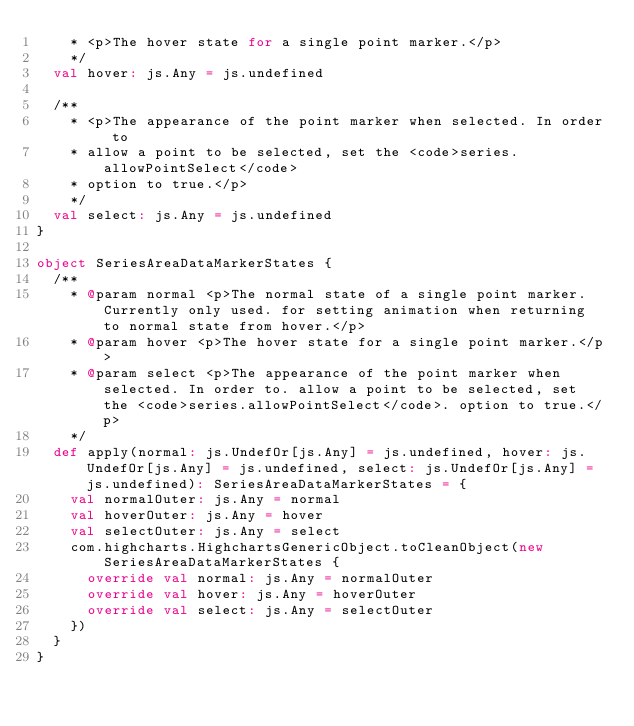Convert code to text. <code><loc_0><loc_0><loc_500><loc_500><_Scala_>    * <p>The hover state for a single point marker.</p>
    */
  val hover: js.Any = js.undefined

  /**
    * <p>The appearance of the point marker when selected. In order to
    * allow a point to be selected, set the <code>series.allowPointSelect</code>
    * option to true.</p>
    */
  val select: js.Any = js.undefined
}

object SeriesAreaDataMarkerStates {
  /**
    * @param normal <p>The normal state of a single point marker. Currently only used. for setting animation when returning to normal state from hover.</p>
    * @param hover <p>The hover state for a single point marker.</p>
    * @param select <p>The appearance of the point marker when selected. In order to. allow a point to be selected, set the <code>series.allowPointSelect</code>. option to true.</p>
    */
  def apply(normal: js.UndefOr[js.Any] = js.undefined, hover: js.UndefOr[js.Any] = js.undefined, select: js.UndefOr[js.Any] = js.undefined): SeriesAreaDataMarkerStates = {
    val normalOuter: js.Any = normal
    val hoverOuter: js.Any = hover
    val selectOuter: js.Any = select
    com.highcharts.HighchartsGenericObject.toCleanObject(new SeriesAreaDataMarkerStates {
      override val normal: js.Any = normalOuter
      override val hover: js.Any = hoverOuter
      override val select: js.Any = selectOuter
    })
  }
}
</code> 